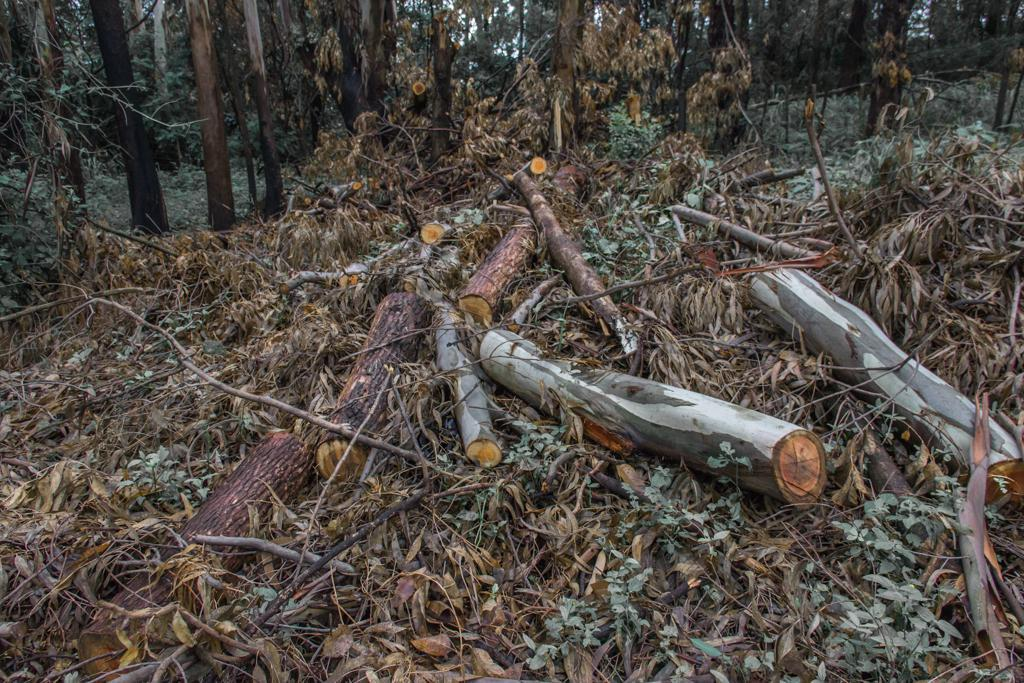What type of vegetation can be seen in the image? There are trees in the image. What is present on the ground beneath the trees? Dry leaves are present in the image. What other objects can be seen in the image? There are wooden logs in the image. How many cakes are hanging from the trees in the image? There are no cakes present in the image; it features trees, dry leaves, and wooden logs. Can you see any stems on the trees in the image? The provided facts do not mention stems on the trees, so we cannot definitively answer that question. 